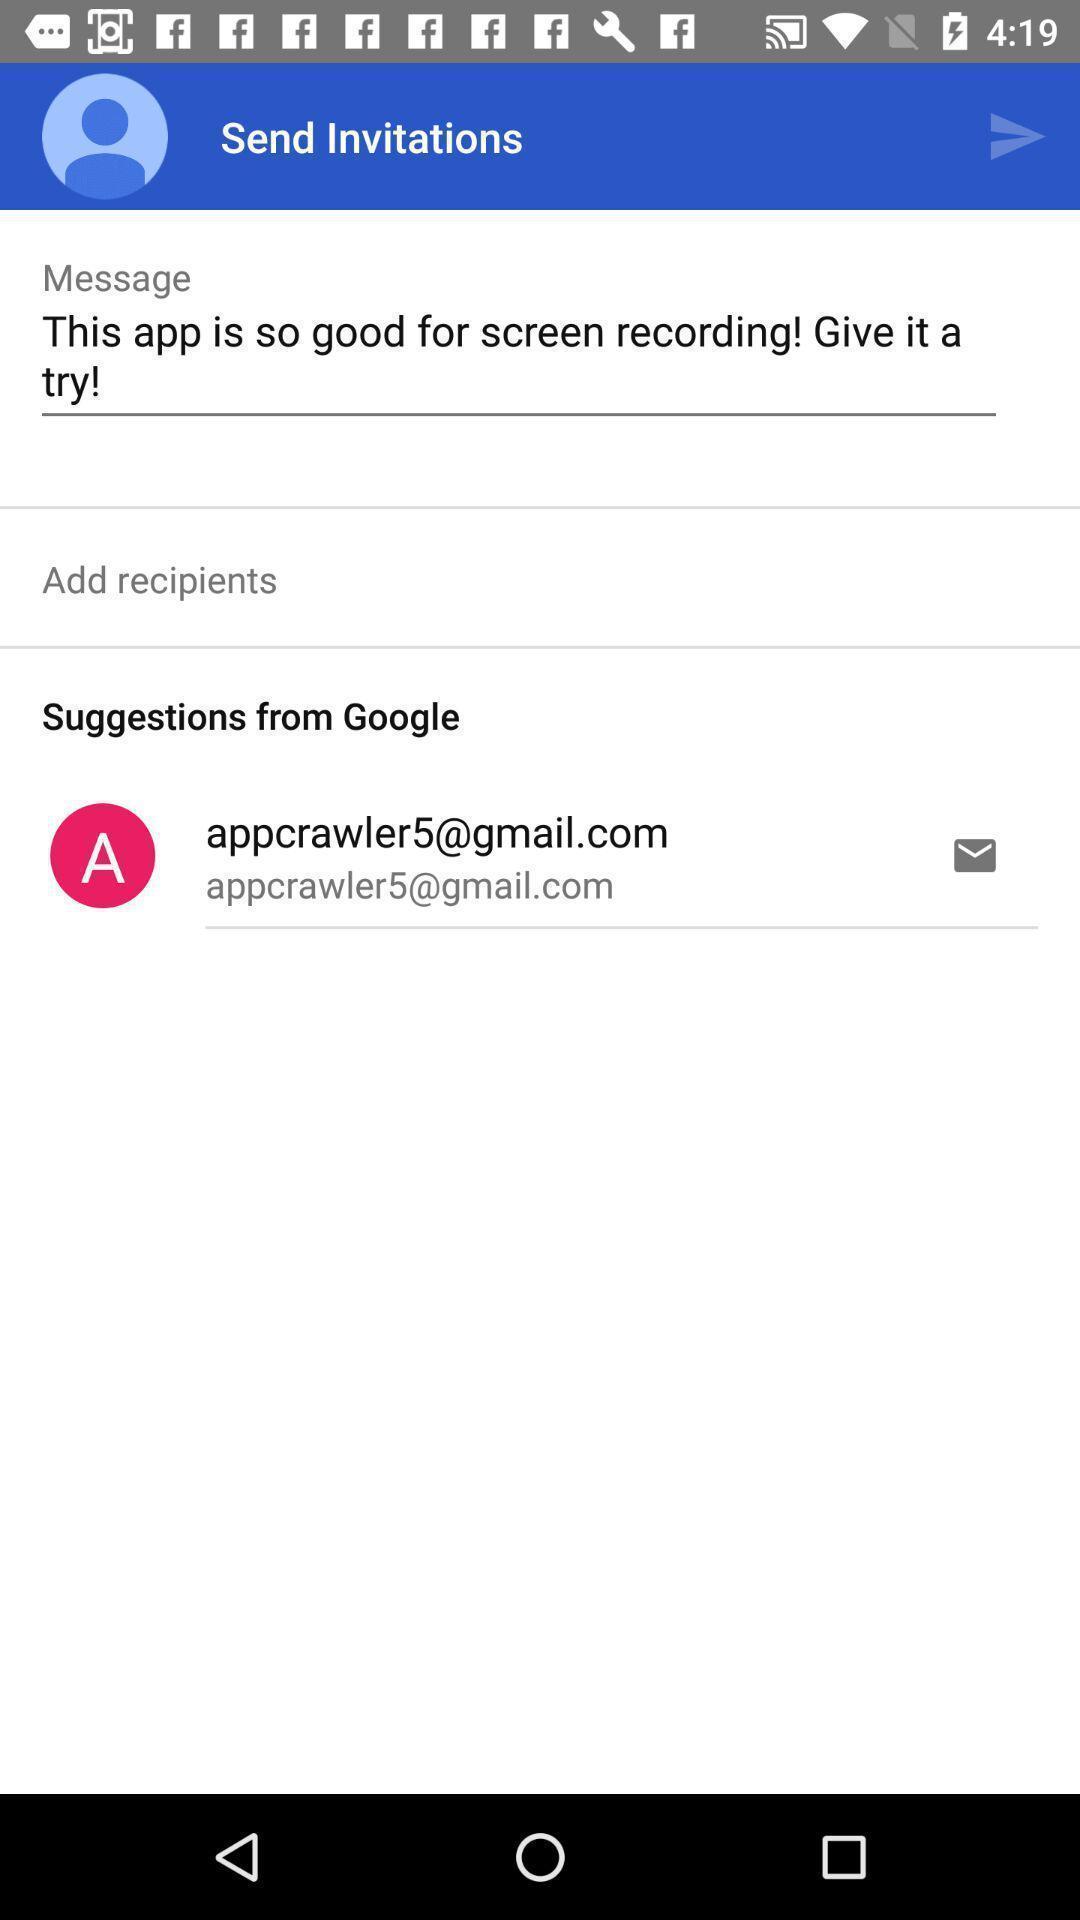Summarize the main components in this picture. Page for sending invitations about application with message. 